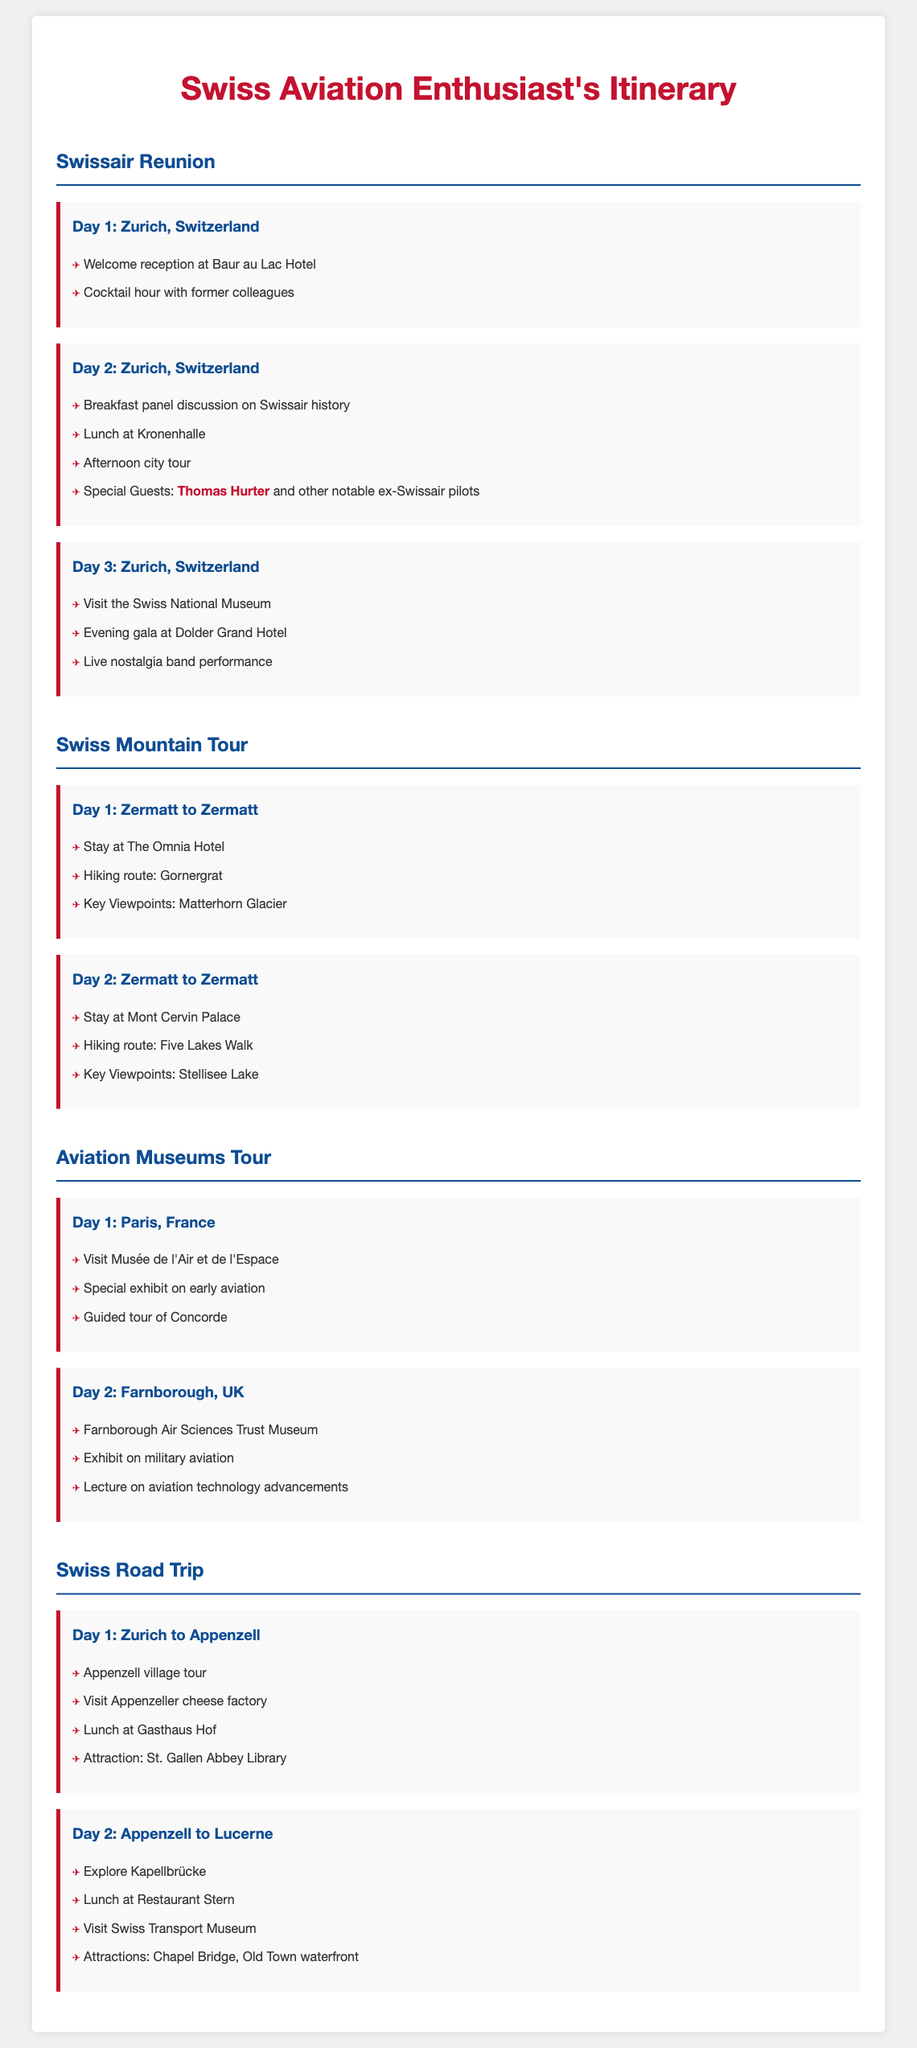What is the location for Day 1 of the Swissair Reunion? The location for Day 1 is stated as Zurich, Switzerland in the document.
Answer: Zurich, Switzerland Who are the special guests on Day 2 of the Swissair Reunion? The special guests mentioned for Day 2 are Thomas Hurter and other notable ex-Swissair pilots.
Answer: Thomas Hurter What hotel is listed for the first night of the Swiss Mountain Tour? The document specifies that the first night of the Swiss Mountain Tour is at The Omnia Hotel.
Answer: The Omnia Hotel What activity is scheduled for Day 1 of the Aviation Museums Tour? The first activity listed for Day 1 is a visit to Musée de l'Air et de l'Espace.
Answer: Visit Musée de l'Air et de l'Espace How many days are allocated for the Swissair Reunion? The document outlines three days for the Swissair Reunion events.
Answer: Three days What is one of the key viewpoints on Day 2 of the Swiss Mountain Tour? The key viewpoint on that day is Stellisee Lake as mentioned in the itinerary.
Answer: Stellisee Lake What attraction is highlighted on Day 1 of the Swiss Road Trip? The attraction highlighted on Day 1 is the Appenzeller cheese factory.
Answer: Appenzeller cheese factory On which day is a live nostalgia band performance scheduled? The live nostalgia band performance is scheduled for Day 3 of the Swissair Reunion.
Answer: Day 3 What is the main theme of the Swissair Reunion itinerary? The main theme is celebrating the airline's storied history and camaraderie among former pilots.
Answer: Celebrating the airline's storied history 